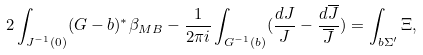Convert formula to latex. <formula><loc_0><loc_0><loc_500><loc_500>2 \int _ { J ^ { - 1 } ( 0 ) } ( G - b ) ^ { * } \beta _ { M B } - \frac { 1 } { 2 \pi i } \int _ { G ^ { - 1 } ( b ) } ( \frac { d J } { J } - \frac { d \overline { J } } { \overline { J } } ) = \int _ { b \Sigma ^ { \prime } } \Xi ,</formula> 